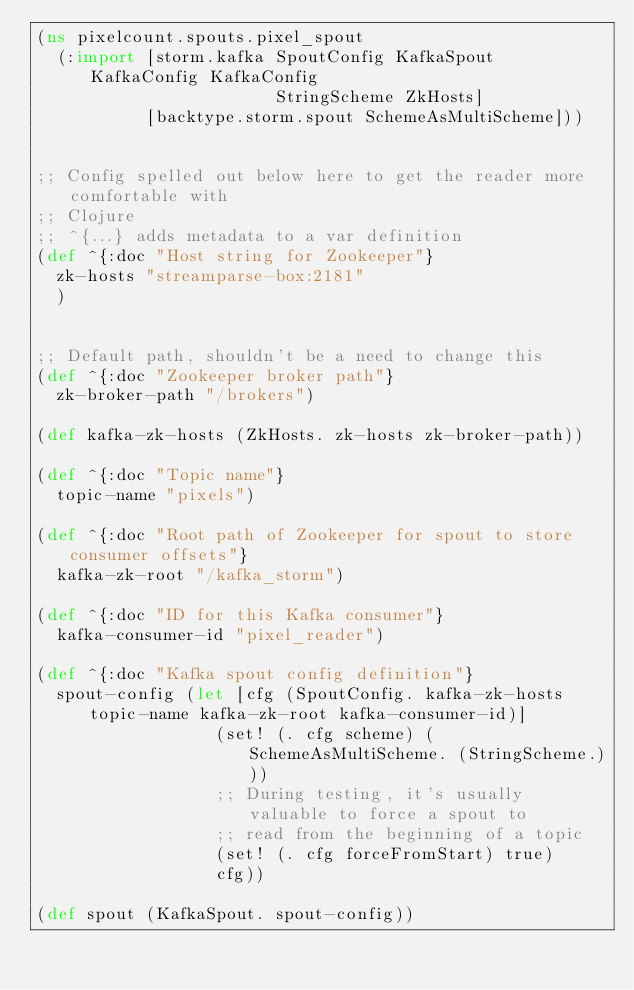<code> <loc_0><loc_0><loc_500><loc_500><_Clojure_>(ns pixelcount.spouts.pixel_spout
  (:import [storm.kafka SpoutConfig KafkaSpout KafkaConfig KafkaConfig
                        StringScheme ZkHosts]
           [backtype.storm.spout SchemeAsMultiScheme]))


;; Config spelled out below here to get the reader more comfortable with
;; Clojure
;; ^{...} adds metadata to a var definition
(def ^{:doc "Host string for Zookeeper"}
  zk-hosts "streamparse-box:2181"
  )


;; Default path, shouldn't be a need to change this
(def ^{:doc "Zookeeper broker path"}
  zk-broker-path "/brokers")

(def kafka-zk-hosts (ZkHosts. zk-hosts zk-broker-path))

(def ^{:doc "Topic name"}
  topic-name "pixels")

(def ^{:doc "Root path of Zookeeper for spout to store consumer offsets"}
  kafka-zk-root "/kafka_storm")

(def ^{:doc "ID for this Kafka consumer"}
  kafka-consumer-id "pixel_reader")

(def ^{:doc "Kafka spout config definition"}
  spout-config (let [cfg (SpoutConfig. kafka-zk-hosts topic-name kafka-zk-root kafka-consumer-id)]
                  (set! (. cfg scheme) (SchemeAsMultiScheme. (StringScheme.)))
                  ;; During testing, it's usually valuable to force a spout to
                  ;; read from the beginning of a topic
                  (set! (. cfg forceFromStart) true)
                  cfg))

(def spout (KafkaSpout. spout-config))
</code> 